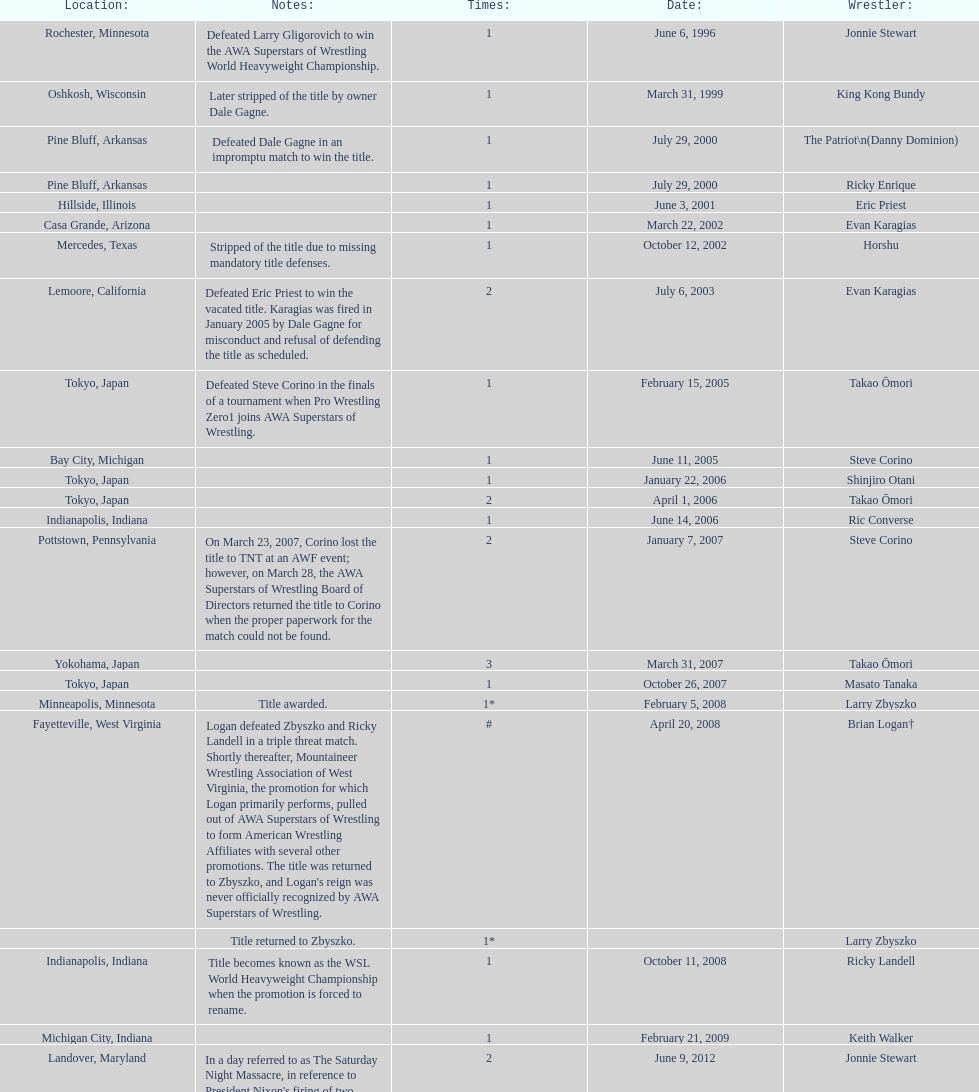The patriot (danny dominion) won the title from what previous holder through an impromptu match? Dale Gagne. 